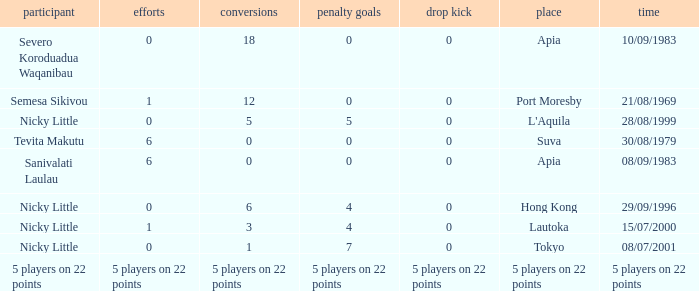How many conversions did Severo Koroduadua Waqanibau have when he has 0 pens? 18.0. 